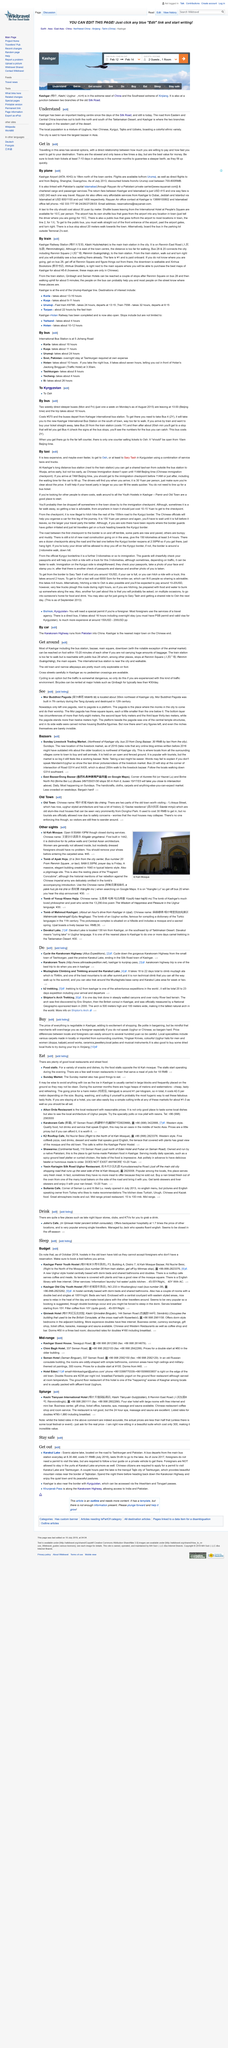Specify some key components in this picture. Mor Buddhist Pagoda is located approximately 30 kilometers northeast of Kashgar city, in a region known for its scenic beauty and rich cultural heritage. Bicycles are rented at major hotels, such as Qinibagh, where people can rent them for their convenience. East Bazaar is least crowded on weekdays. The easiest way to find one's way when lost in a city is to board bus 28 and alight at Renmin Square. Kashgar Airport is located 18km north of the town centre, which can be accessed by traveling north for approximately 18 kilometers from the heart of the city. The airport is situated in a region that is known for its stunning natural beauty and rich cultural heritage. 